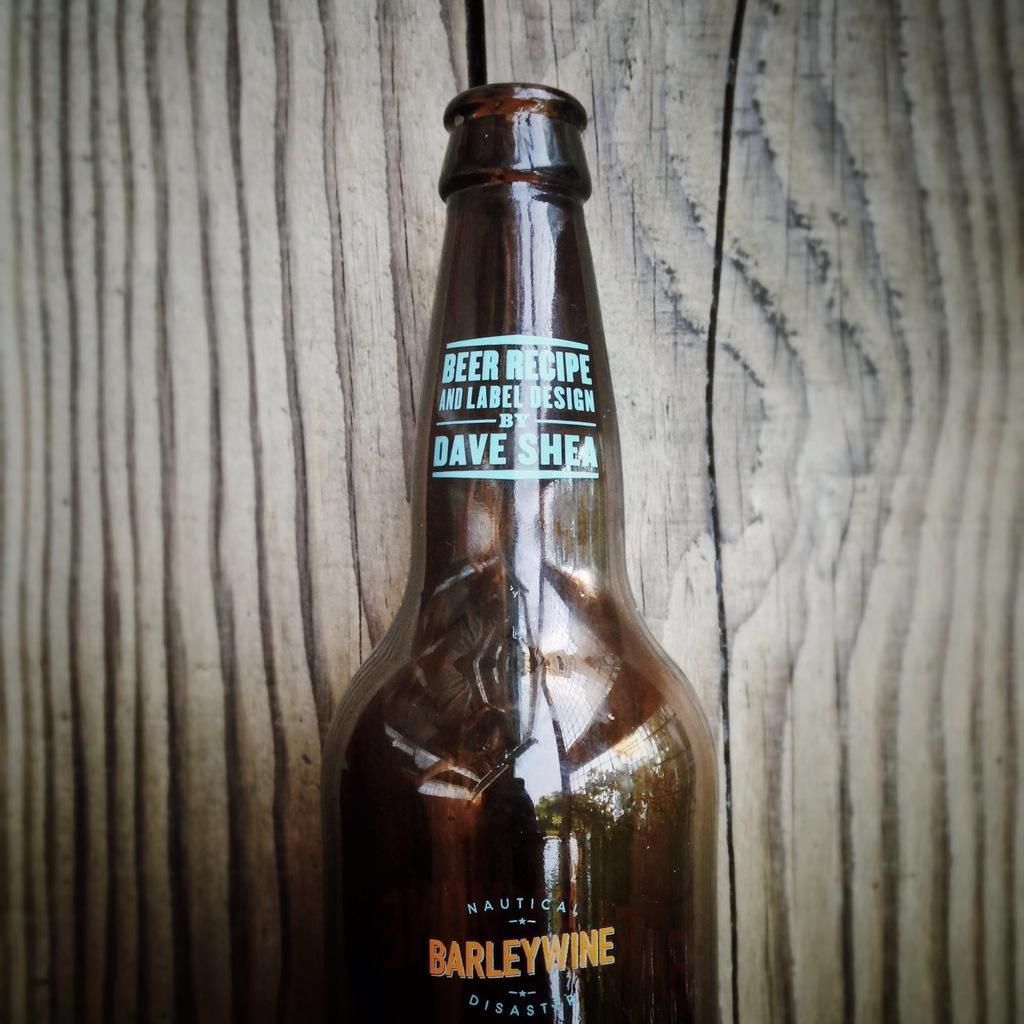<image>
Relay a brief, clear account of the picture shown. Half a barelywine beer bottle displayed against a wood background. 